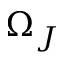Convert formula to latex. <formula><loc_0><loc_0><loc_500><loc_500>\Omega _ { J }</formula> 